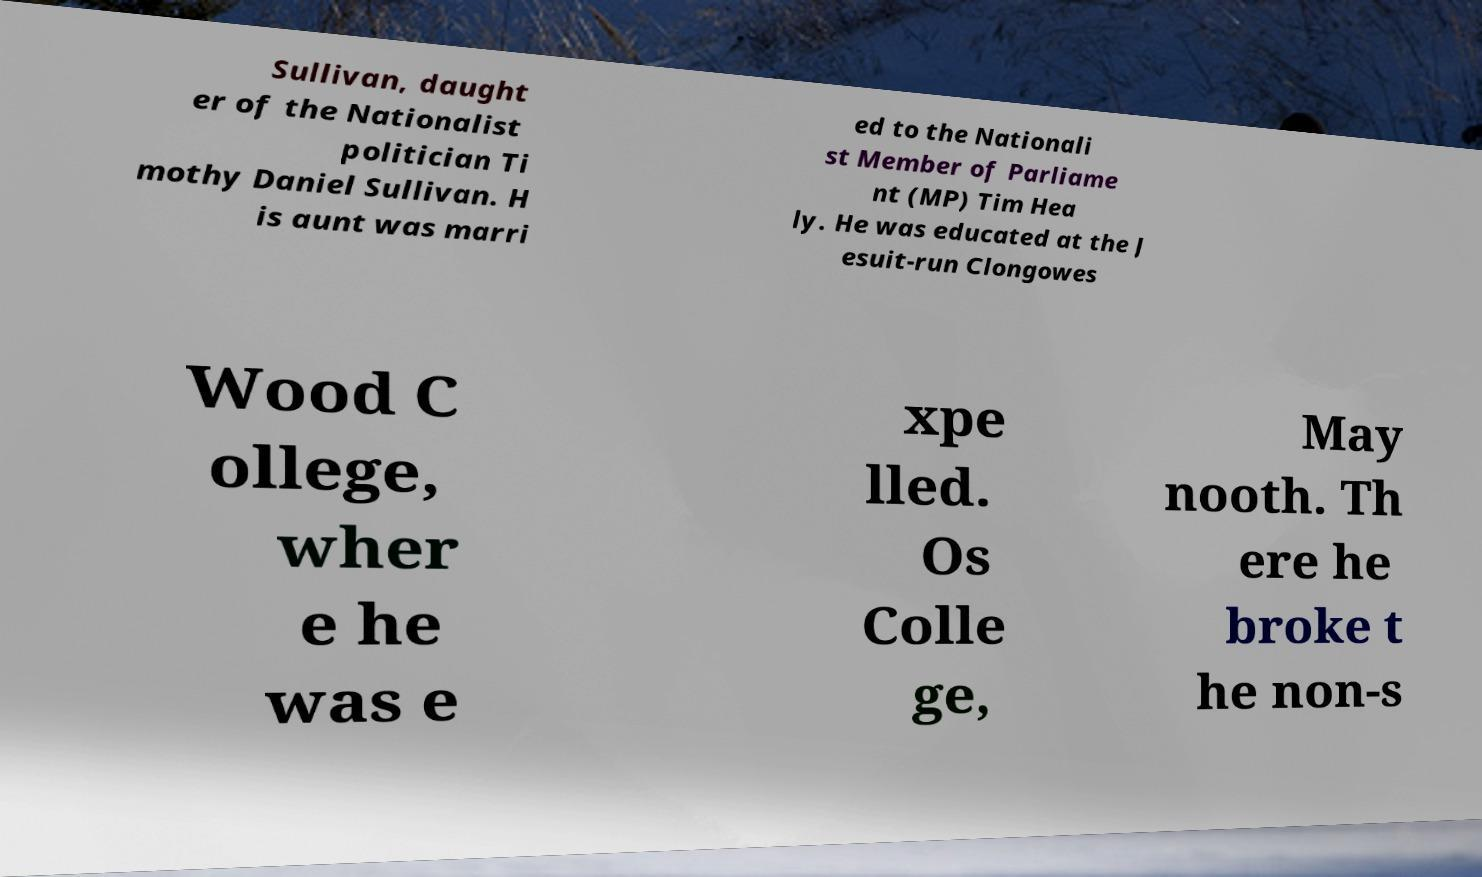For documentation purposes, I need the text within this image transcribed. Could you provide that? Sullivan, daught er of the Nationalist politician Ti mothy Daniel Sullivan. H is aunt was marri ed to the Nationali st Member of Parliame nt (MP) Tim Hea ly. He was educated at the J esuit-run Clongowes Wood C ollege, wher e he was e xpe lled. Os Colle ge, May nooth. Th ere he broke t he non-s 